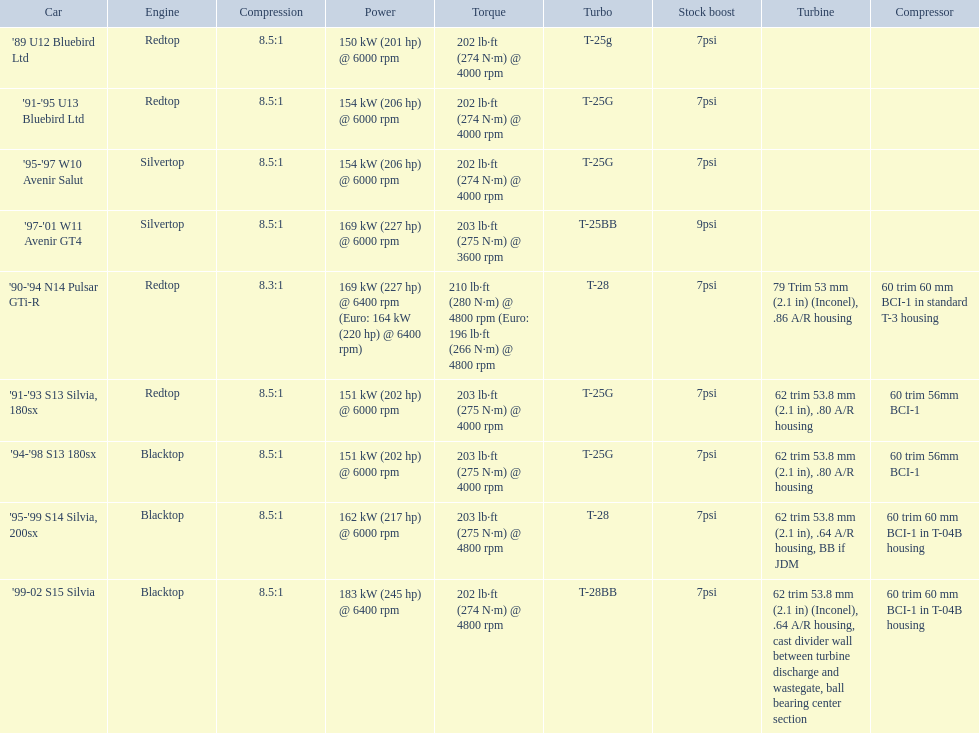What are all the automobiles? '89 U12 Bluebird Ltd, '91-'95 U13 Bluebird Ltd, '95-'97 W10 Avenir Salut, '97-'01 W11 Avenir GT4, '90-'94 N14 Pulsar GTi-R, '91-'93 S13 Silvia, 180sx, '94-'98 S13 180sx, '95-'99 S14 Silvia, 200sx, '99-02 S15 Silvia. What is their evaluated power? 150 kW (201 hp) @ 6000 rpm, 154 kW (206 hp) @ 6000 rpm, 154 kW (206 hp) @ 6000 rpm, 169 kW (227 hp) @ 6000 rpm, 169 kW (227 hp) @ 6400 rpm (Euro: 164 kW (220 hp) @ 6400 rpm), 151 kW (202 hp) @ 6000 rpm, 151 kW (202 hp) @ 6000 rpm, 162 kW (217 hp) @ 6000 rpm, 183 kW (245 hp) @ 6400 rpm. Which vehicle has the most power? '99-02 S15 Silvia. 